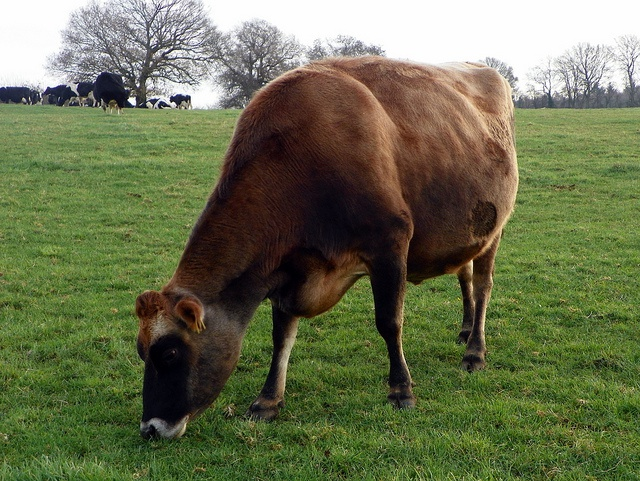Describe the objects in this image and their specific colors. I can see cow in white, black, maroon, and gray tones, cow in white, black, navy, gray, and olive tones, cow in white, black, navy, gray, and blue tones, cow in white, black, darkgray, and navy tones, and cow in white, black, lightgray, darkgray, and gray tones in this image. 